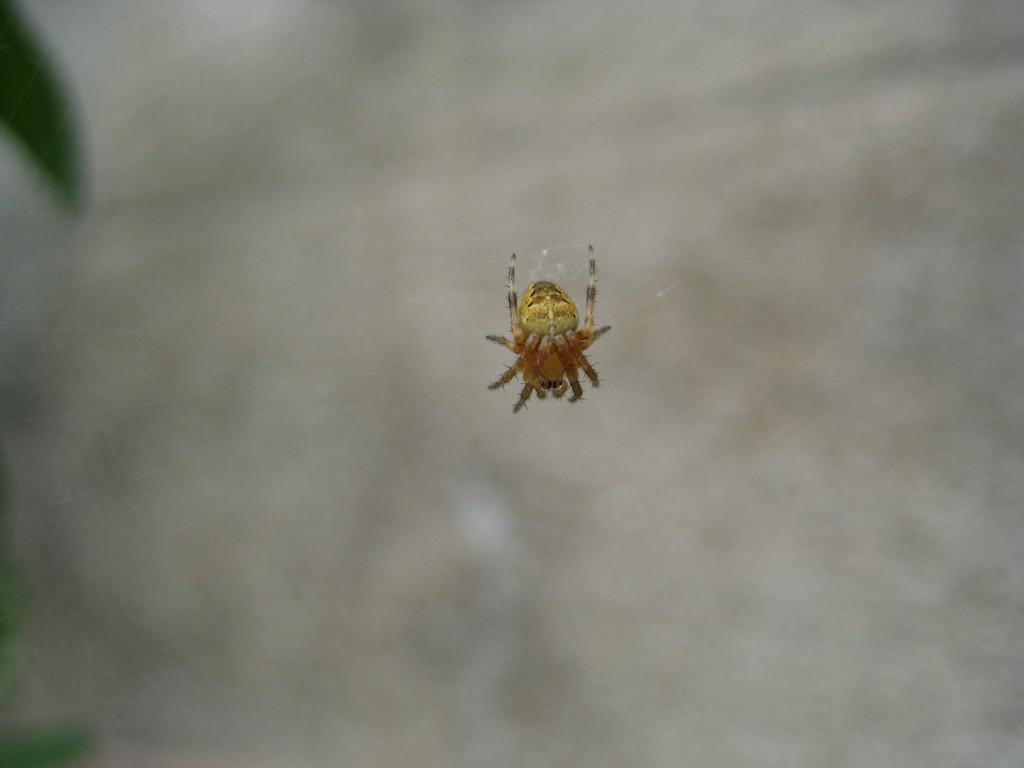In one or two sentences, can you explain what this image depicts? In the center of the picture there is a spider in its web. The background is blurred. 